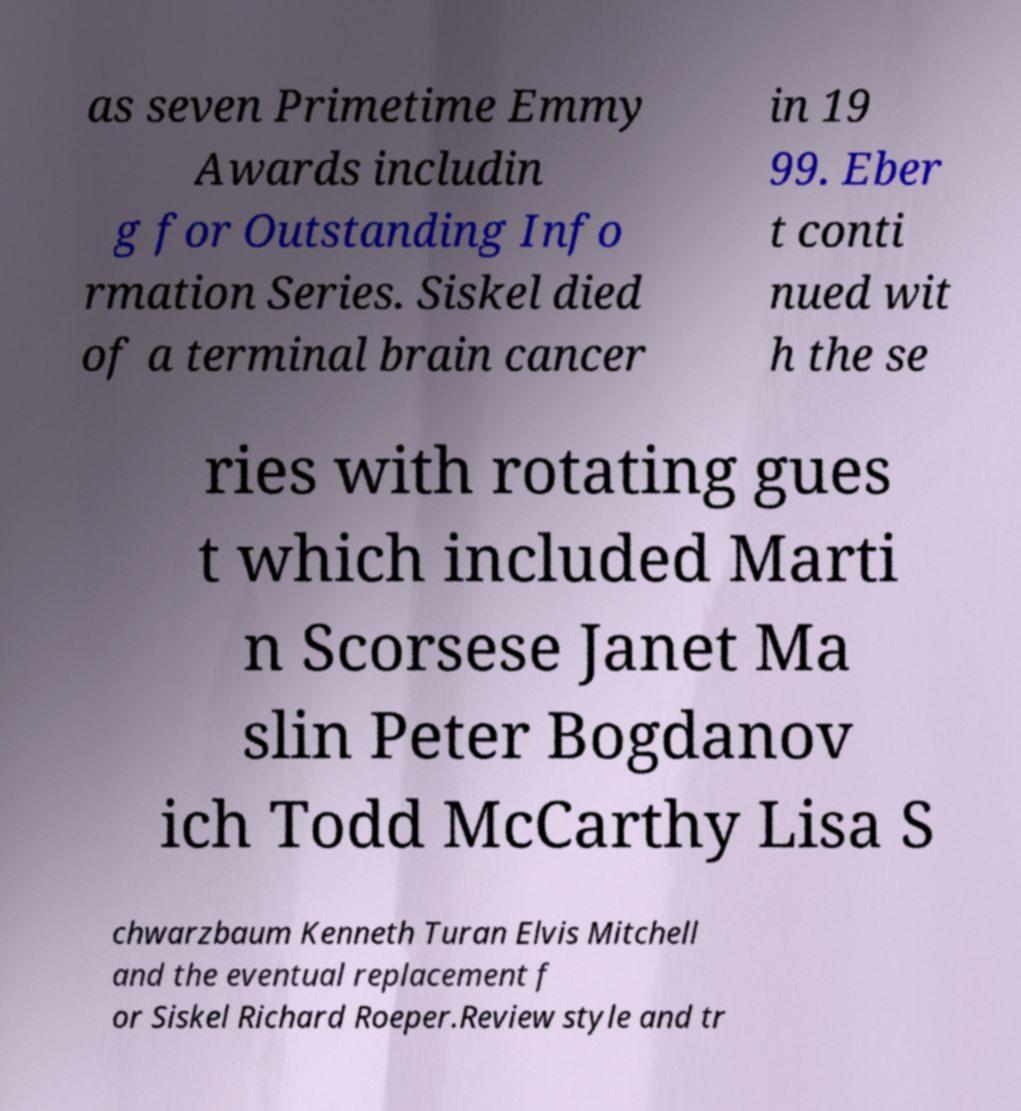I need the written content from this picture converted into text. Can you do that? as seven Primetime Emmy Awards includin g for Outstanding Info rmation Series. Siskel died of a terminal brain cancer in 19 99. Eber t conti nued wit h the se ries with rotating gues t which included Marti n Scorsese Janet Ma slin Peter Bogdanov ich Todd McCarthy Lisa S chwarzbaum Kenneth Turan Elvis Mitchell and the eventual replacement f or Siskel Richard Roeper.Review style and tr 